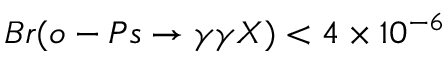<formula> <loc_0><loc_0><loc_500><loc_500>B r ( o - P s \rightarrow \gamma \gamma X ) < 4 \times 1 0 ^ { - 6 }</formula> 